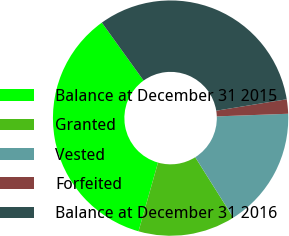Convert chart. <chart><loc_0><loc_0><loc_500><loc_500><pie_chart><fcel>Balance at December 31 2015<fcel>Granted<fcel>Vested<fcel>Forfeited<fcel>Balance at December 31 2016<nl><fcel>35.67%<fcel>13.34%<fcel>16.64%<fcel>1.97%<fcel>32.37%<nl></chart> 